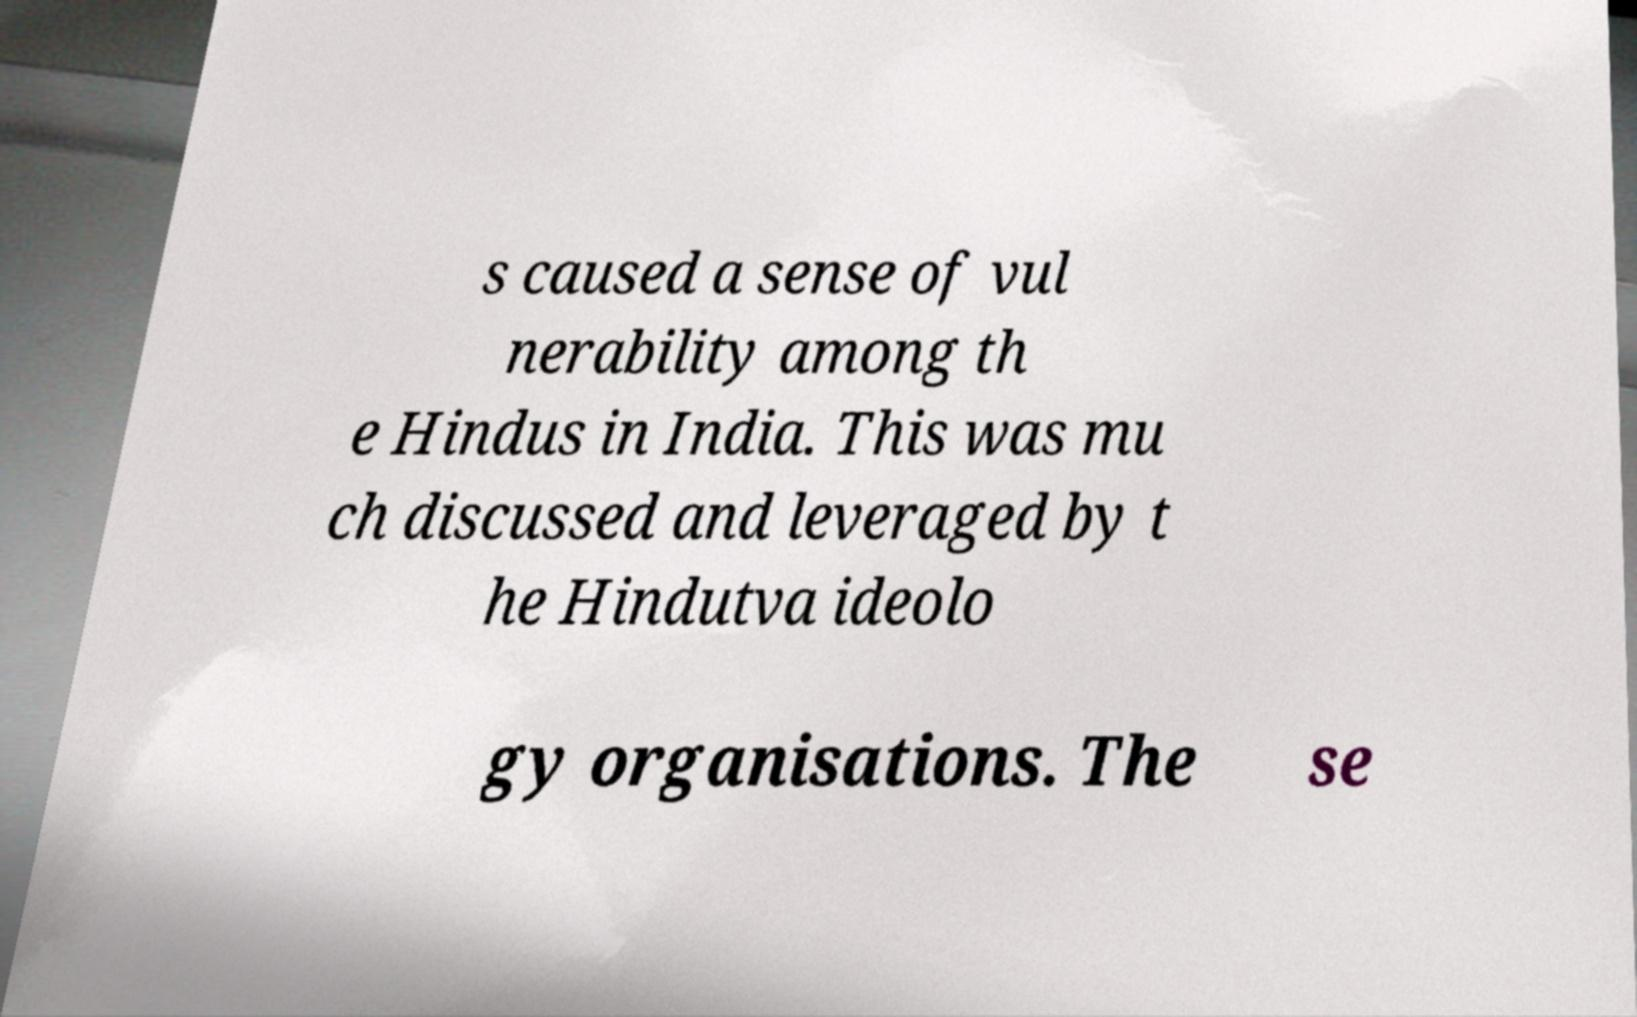Please identify and transcribe the text found in this image. s caused a sense of vul nerability among th e Hindus in India. This was mu ch discussed and leveraged by t he Hindutva ideolo gy organisations. The se 